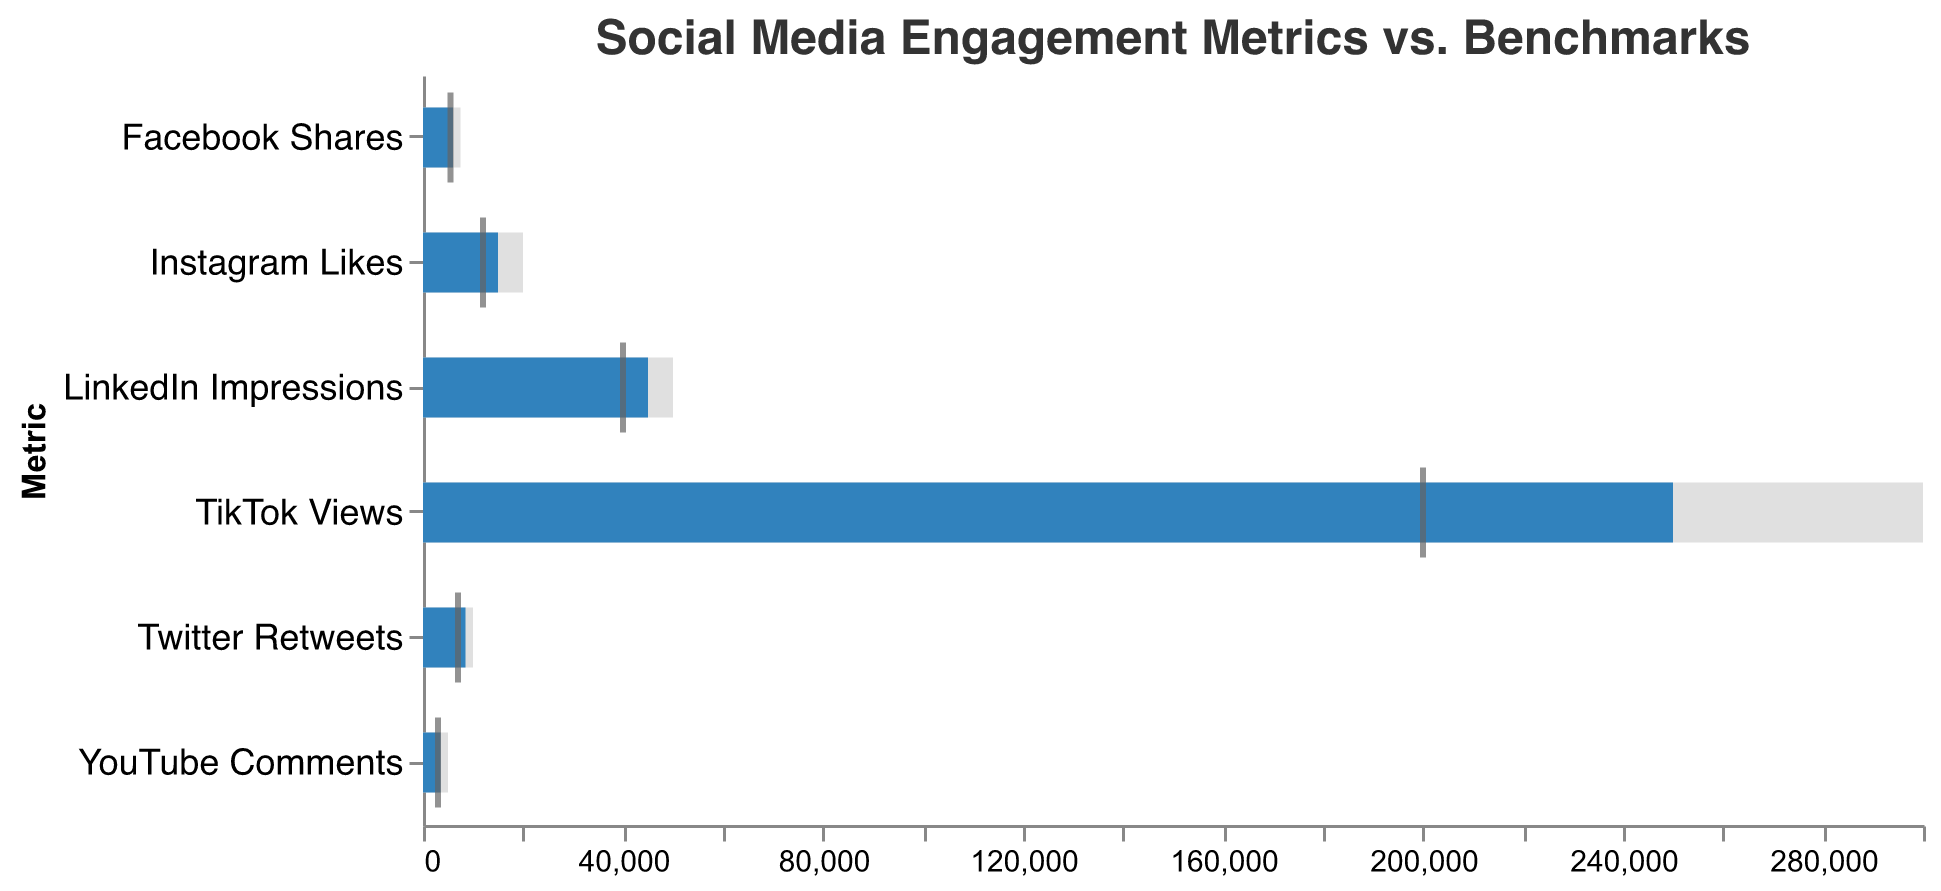What's the title of the figure? The title of the figure is typically placed at the top and is often stylized to highlight the main topic. In this case, it should refer to the comparison of social media engagement metrics to benchmarks.
Answer: Social Media Engagement Metrics vs. Benchmarks Which metric has the highest actual value? To find the metric with the highest actual value, we need to scan the "Actual" bars and identify the one with the greatest length.
Answer: TikTok Views How much does the actual number of Twitter Retweets differ from the target? Look at the actual value and the target value for Twitter Retweets, then subtract the actual value from the target value (10,000 - 8,500).
Answer: 1,500 Which metric meets or exceeds the industry benchmark but does not reach its target? We need to identify the bars where the actual value (blue bar) meets or exceeds the benchmark (tick mark) but falls short of the target (gray bar).
Answer: Instagram Likes Are there any metrics where the actual values exceed the target values? Compare the length of the blue bars (Actual) against the gray bars (Target).
Answer: No What is the average actual value across all metrics? Add all the actual values together (15,000 + 8,500 + 6,000 + 250,000 + 3,500 + 45,000) and then divide by the number of metrics (6). The total sum is 328,000 and dividing by 6 gives us the average.
Answer: 54,667 Which platform has the closest actual engagement to its target? Look for the smallest difference between the blue bar (Actual) and the gray bar (Target).
Answer: LinkedIn Impressions How does the actual number of Instagram Likes compare to YouTube Comments? Compare the actual values of Instagram Likes and YouTube Comments by looking at the lengths of their blue bars.
Answer: Instagram Likes are higher What is the sum of the benchmarks for TikTok Views and LinkedIn Impressions? Add the benchmark values for TikTok Views and LinkedIn Impressions (200,000 + 40,000).
Answer: 240,000 